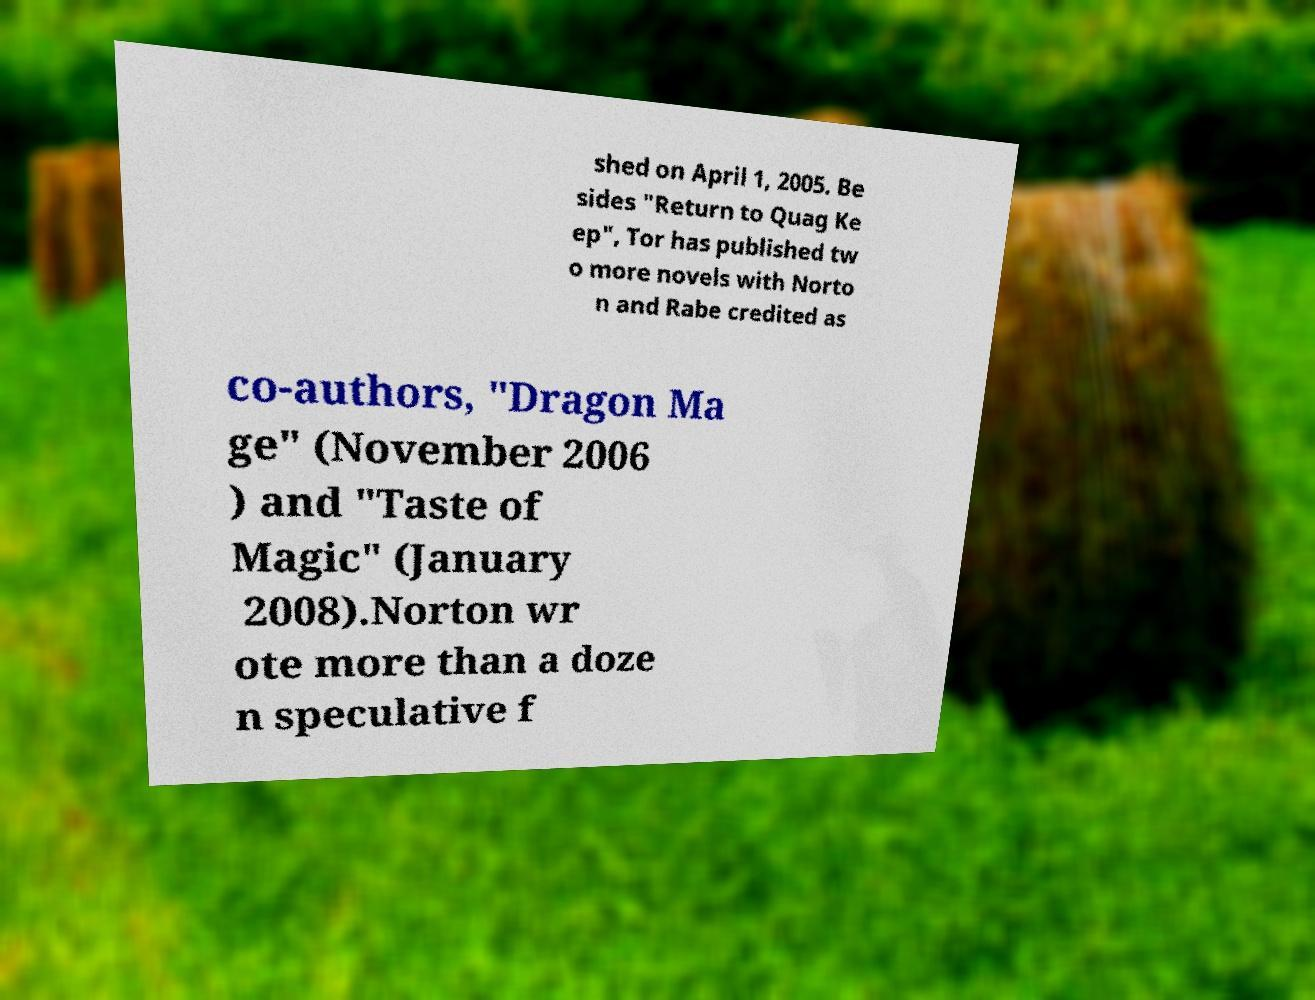For documentation purposes, I need the text within this image transcribed. Could you provide that? shed on April 1, 2005. Be sides "Return to Quag Ke ep", Tor has published tw o more novels with Norto n and Rabe credited as co-authors, "Dragon Ma ge" (November 2006 ) and "Taste of Magic" (January 2008).Norton wr ote more than a doze n speculative f 